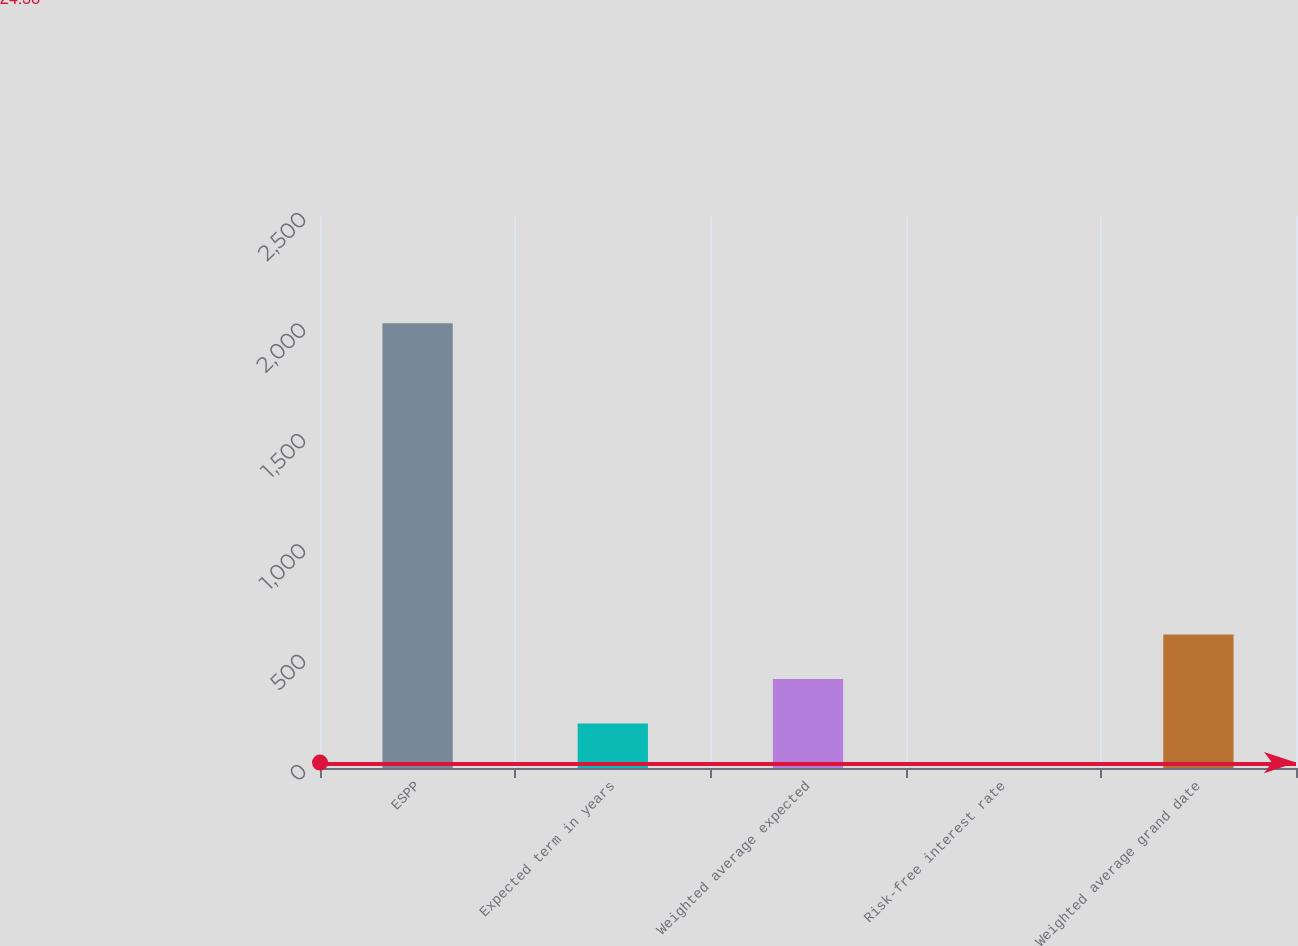Convert chart. <chart><loc_0><loc_0><loc_500><loc_500><bar_chart><fcel>ESPP<fcel>Expected term in years<fcel>Weighted average expected<fcel>Risk-free interest rate<fcel>Weighted average grand date<nl><fcel>2014<fcel>201.47<fcel>402.86<fcel>0.08<fcel>604.25<nl></chart> 